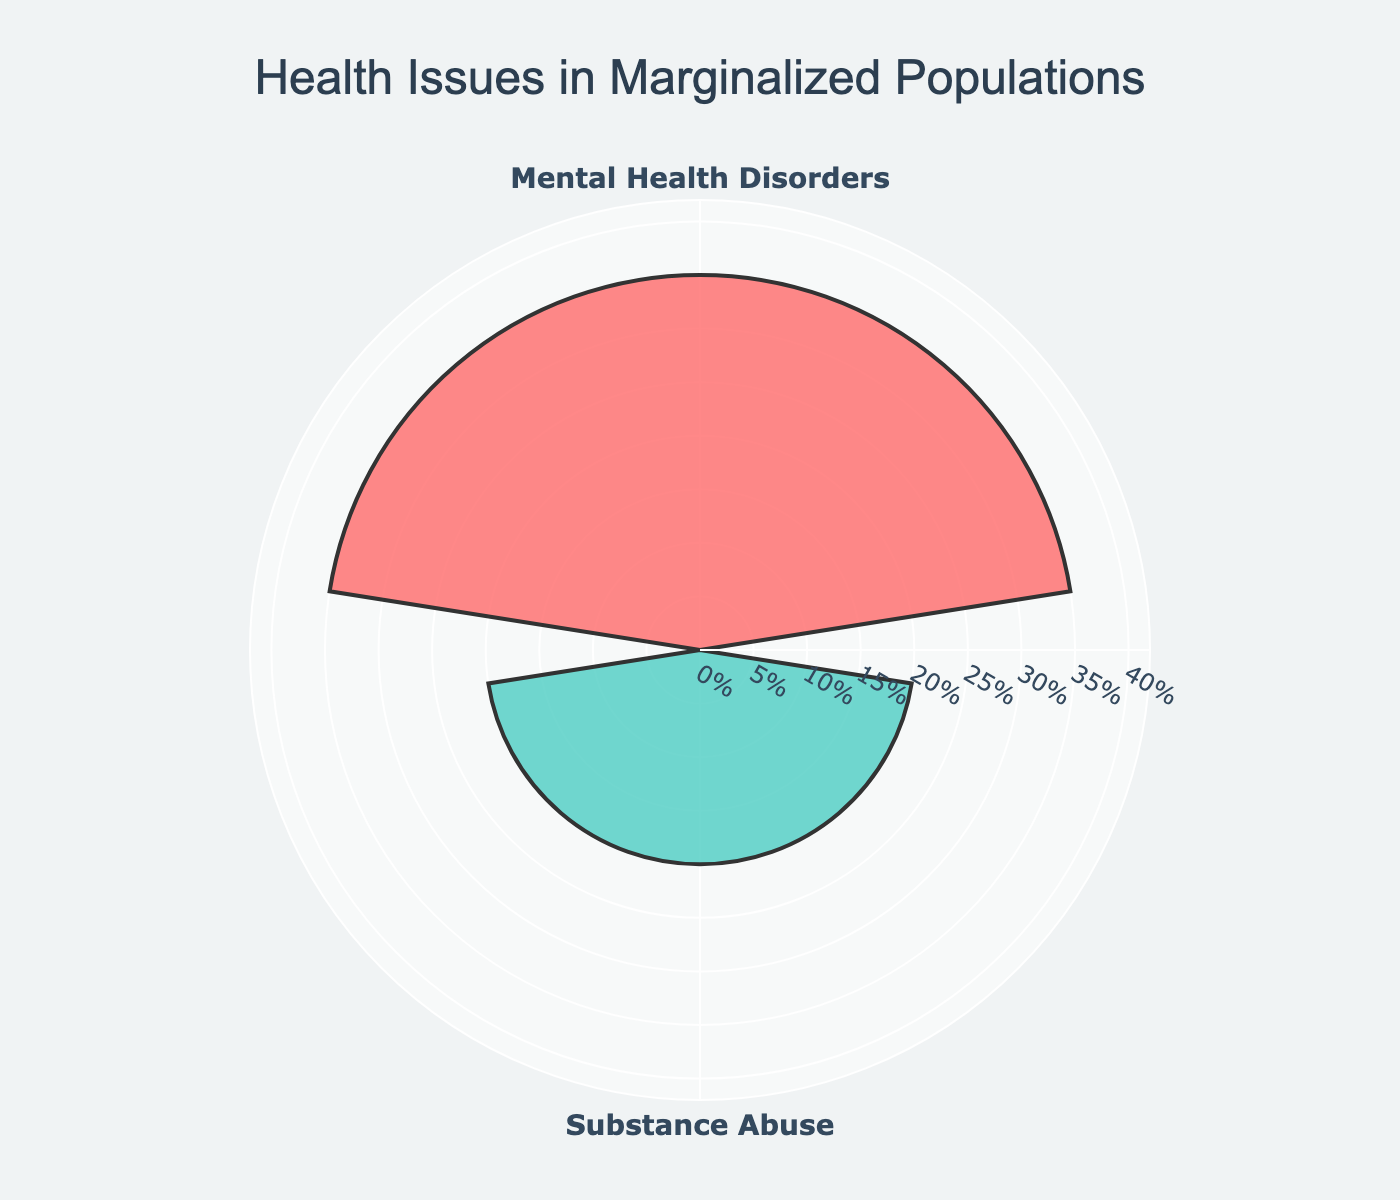What is the title of the chart? The title of the chart is typically displayed at the top and indicates the subject matter of the visualization. Here, it is "Health Issues in Marginalized Populations".
Answer: Health Issues in Marginalized Populations How many health issues are represented in the chart? By observing the labels on the chart, you can identify the number of unique health issues. There are two health issues listed: Mental Health Disorders and Substance Abuse.
Answer: 2 What color represents Mental Health Disorders? The chart uses distinct colors to differentiate between health issues. Mental Health Disorders is represented by the color that corresponds to its percentage. It is the first segment, which is in a shade of red.
Answer: Red Which health issue has a higher percentage? By comparing the lengths of the segments and the associated percentages, we see that Mental Health Disorders has a higher percentage (35%) than Substance Abuse (20%).
Answer: Mental Health Disorders What is the combined percentage of both health issues? Adding the percentages of both health issues: 35% (Mental Health Disorders) + 20% (Substance Abuse) equals 55%.
Answer: 55% How does the percentage of Substance Abuse compare to Mental Health Disorders? Substance Abuse has a lower percentage compared to Mental Health Disorders. To be precise, it is 15% lower (35% - 20%).
Answer: 15% lower By how much does Mental Health Disorders exceed Substance Abuse in percentage? The excess percentage is the difference between the two values: 35% (Mental Health Disorders) - 20% (Substance Abuse) = 15%.
Answer: 15% What is the range of the percentages displayed on the chart? The range can be found by subtracting the smallest percentage (Substance Abuse, 20%) from the largest percentage (Mental Health Disorders, 35%): 35% - 20% = 15%.
Answer: 15% Where is the percentage annotation for Substance Abuse placed relative to Mental Health Disorders? The percentage annotation for Substance Abuse (20%) is placed closer to the center of the chart compared to the annotation for Mental Health Disorders (35%), which extends farther outwards.
Answer: Closer to the center Which health issue's segment is larger on the chart? By comparing the radial distances from the center, the Mental Health Disorders segment is larger since it has a greater percentage (35%) compared to Substance Abuse (20%).
Answer: Mental Health Disorders 